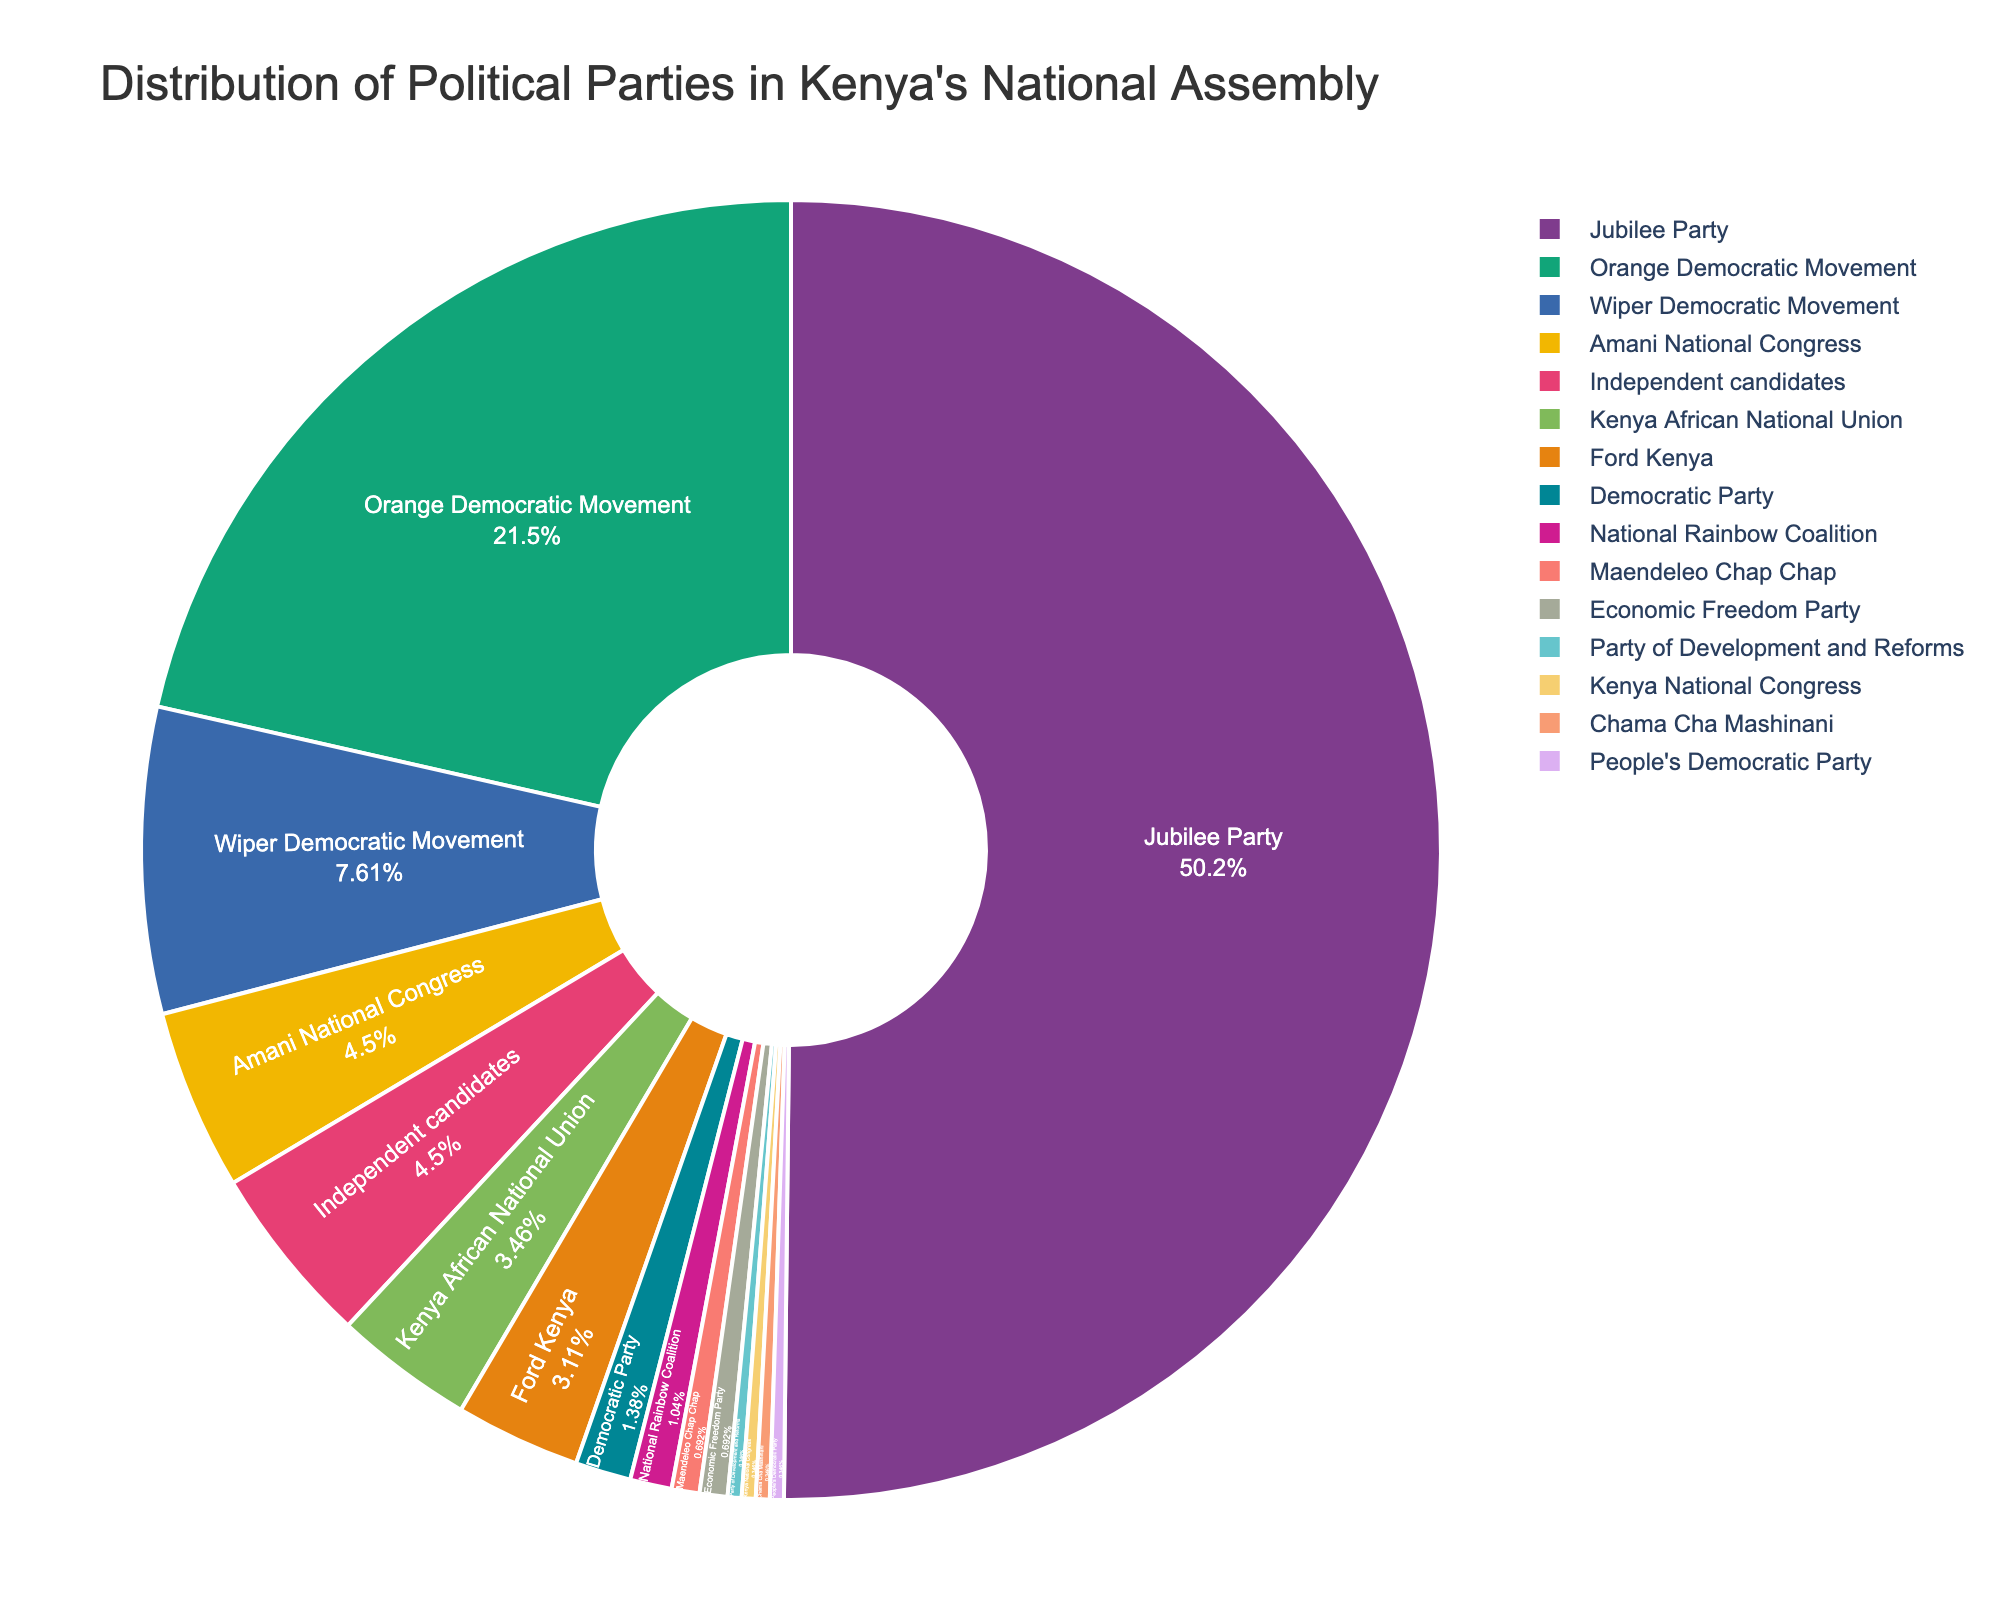What percentage of seats does the Jubilee Party hold? The pie chart shows that each segment is proportional to the number of seats held by each party. By looking at the text inside the largest segment labeled "Jubilee Party," the percentage displayed represents the proportion of seats held by the Jubilee Party.
Answer: ~54% Which party holds the second most seats in the National Assembly? Observe the pie chart and identify the second largest segment by area and the associated label, which represents the party with the second most seats.
Answer: Orange Democratic Movement How many more seats does the Jubilee Party have compared to the Wiper Democratic Movement? From the pie chart, the Jubilee Party has 145 seats, and the Wiper Democratic Movement has 22 seats. By subtracting the latter from the former (145 - 22), we get the difference in seats.
Answer: 123 What is the combined number of seats held by independent candidates and the Amani National Congress? The pie chart shows that Independent candidates have 13 seats and the Amani National Congress has 13 seats. Adding these two numbers together (13+13) provides the combined seats.
Answer: 26 Which party has a larger representation, Kenya African National Union or Ford Kenya, and what is the difference in the number of seats between them? According to the pie chart, Kenya African National Union has 10 seats while Ford Kenya has 9 seats. By comparing these numbers, we see that Kenya African National Union has more seats. The difference is 10 - 9 = 1 seat.
Answer: Kenya African National Union, 1 seat What is the ratio of seats held by the Orange Democratic Movement compared to the Maendeleo Chap Chap? The pie chart shows that the Orange Democratic Movement holds 62 seats, and Maendeleo Chap Chap holds 2 seats. By dividing these, we get the ratio 62/2.
Answer: 31:1 Which party holds the smallest number of seats in the National Assembly? By observing the text labels inside the smallest segments of the pie chart, we can see which party holds only one seat. These are Kenya National Congress, Chama Cha Mashinani, People's Democratic Party, and Party of Development and Reforms, each having the smallest number of seats (1 seat each).
Answer: Kenya National Congress, Chama Cha Mashinani, People's Democratic Party, Party of Development and Reforms What is the total number of seats held by the Democratic Party, National Rainbow Coalition, and Maendeleo Chap Chap combined? The pie chart reveals that the Democratic Party holds 4 seats, the National Rainbow Coalition holds 3 seats, and Maendeleo Chap Chap holds 2 seats. Summing these numbers (4+3+2) gives the total number of seats combined.
Answer: 9 